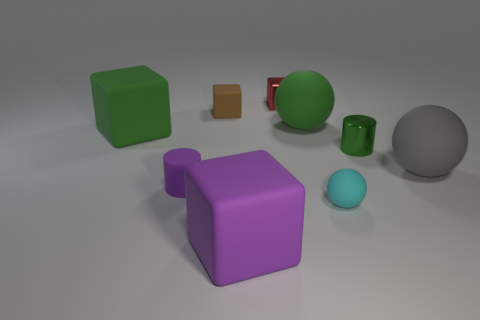Subtract all matte blocks. How many blocks are left? 1 Subtract all red cubes. How many cubes are left? 3 Subtract all blue cubes. Subtract all green cylinders. How many cubes are left? 4 Add 1 big purple rubber things. How many objects exist? 10 Subtract all cubes. How many objects are left? 5 Subtract 0 gray cylinders. How many objects are left? 9 Subtract all large metallic balls. Subtract all green rubber blocks. How many objects are left? 8 Add 7 green cylinders. How many green cylinders are left? 8 Add 3 small brown things. How many small brown things exist? 4 